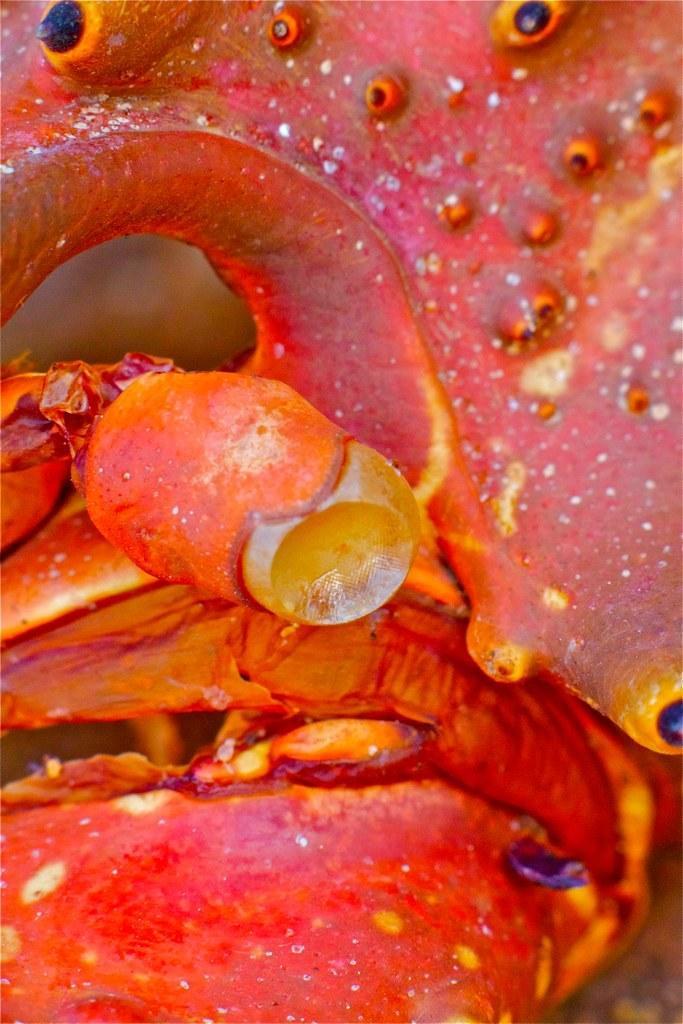Could you give a brief overview of what you see in this image? In this picture we can see an object which is in orange, yellow and black in color. 